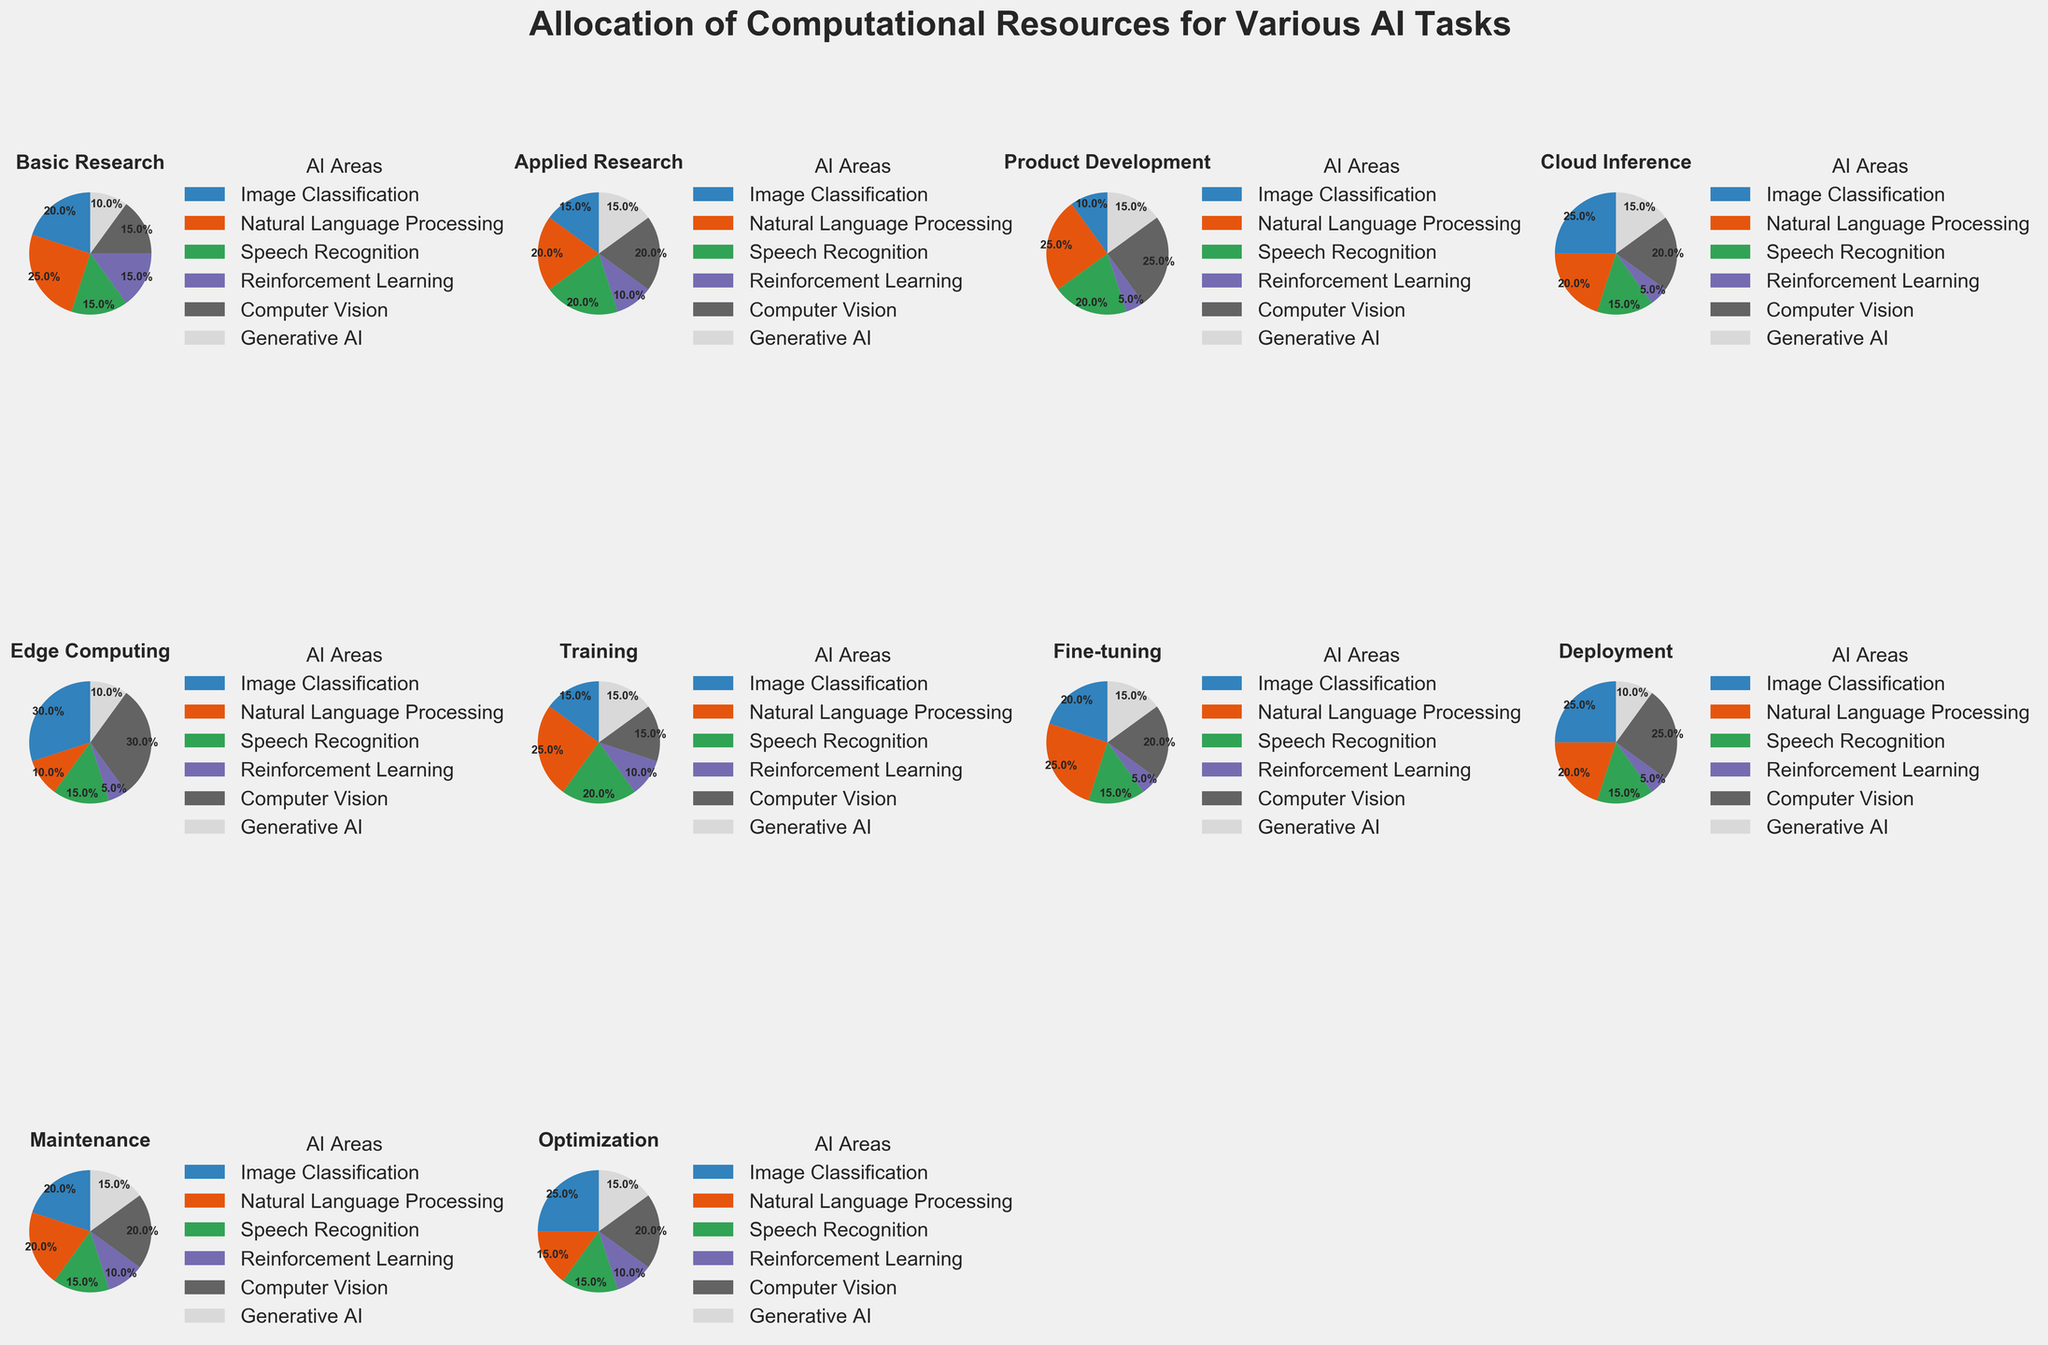What percentage of computational resources is allocated to Image Classification in the Product Development task? Locate the Product Development pie chart and find the segment labeled "Image Classification". The percentage from the segment shows the allocation.
Answer: 10% Which task allocates the least percentage of computational resources to Speech Recognition? Compare all tasks' Speech Recognition segments and find the one with the smallest percentage.
Answer: Edge Computing How do the resource allocations for Generative AI compare between Basic Research and Applied Research tasks? Look at the pie charts for Basic Research and Applied Research, then compare the segments labeled "Generative AI". Basic Research allocates 10% while Applied Research allocates 15%.
Answer: Applied Research allocates 5% more resources What is the combined percentage allocated to Image Classification across Training and Maintenance tasks? Identify the segments labeled "Image Classification" in the Training and Maintenance pie charts, sum their percentages. Training = 15%, Maintenance = 20%, combined = 35%.
Answer: 35% Which task has the highest allocation for Computer Vision? Locate and compare the "Computer Vision" segments across all pie charts. Edge Computing has the highest with 30%.
Answer: Edge Computing Which two tasks have equal allocation of resources for Natural Language Processing? Look for the "Natural Language Processing" segments and find two tasks with equal percentages. Basic Research and Training both allocate 25%.
Answer: Basic Research, Training How does the allocation of resources for Reinforcement Learning in Cloud Inference compare to that in Deployment? Find the "Reinforcement Learning" segments in the Cloud Inference and Deployment pie charts. Both tasks allocate 5%.
Answer: Equal (5%) What is the average percentage allocated to Generative AI across all tasks? Sum the percentages allocated to Generative AI for each task and divide by the number of tasks (10). (10+15+15+15+10+15+15+10+15+15)/10 = 13.5%
Answer: 13.5% How much more resources are allocated to Edge Computing compared to Deployment for Image Classification? Compare the "Image Classification" segments in Edge Computing (30%) and Deployment (25%). 30% - 25% = 5%.
Answer: 5% more What is the difference in resource allocation for Natural Language Processing between Applied Research and Maintenance? Compare the "Natural Language Processing" segments in Applied Research (20%) and Maintenance (20%). 20% - 20% = 0.
Answer: 0% difference 